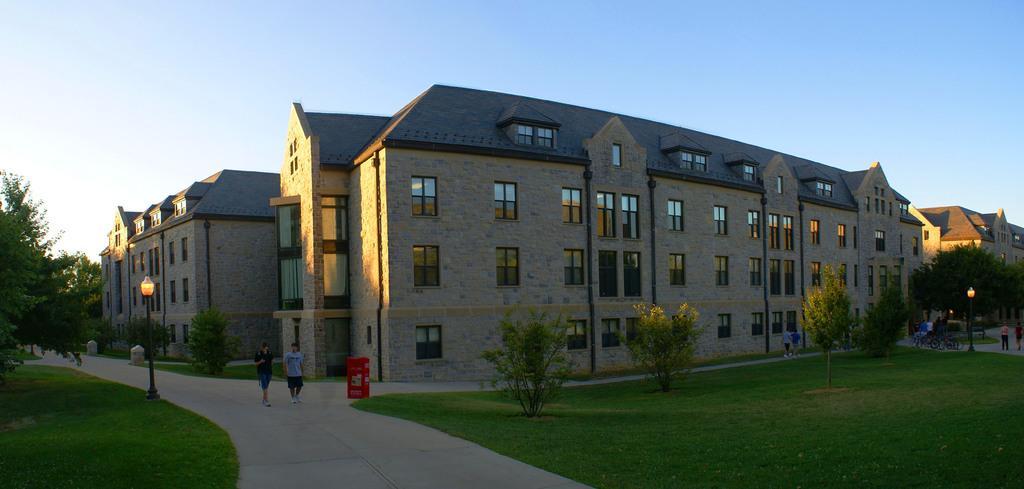Describe this image in one or two sentences. On the left side 2 men are walking, in the middle there are trees, there are buildings. At the top it is the sky. 